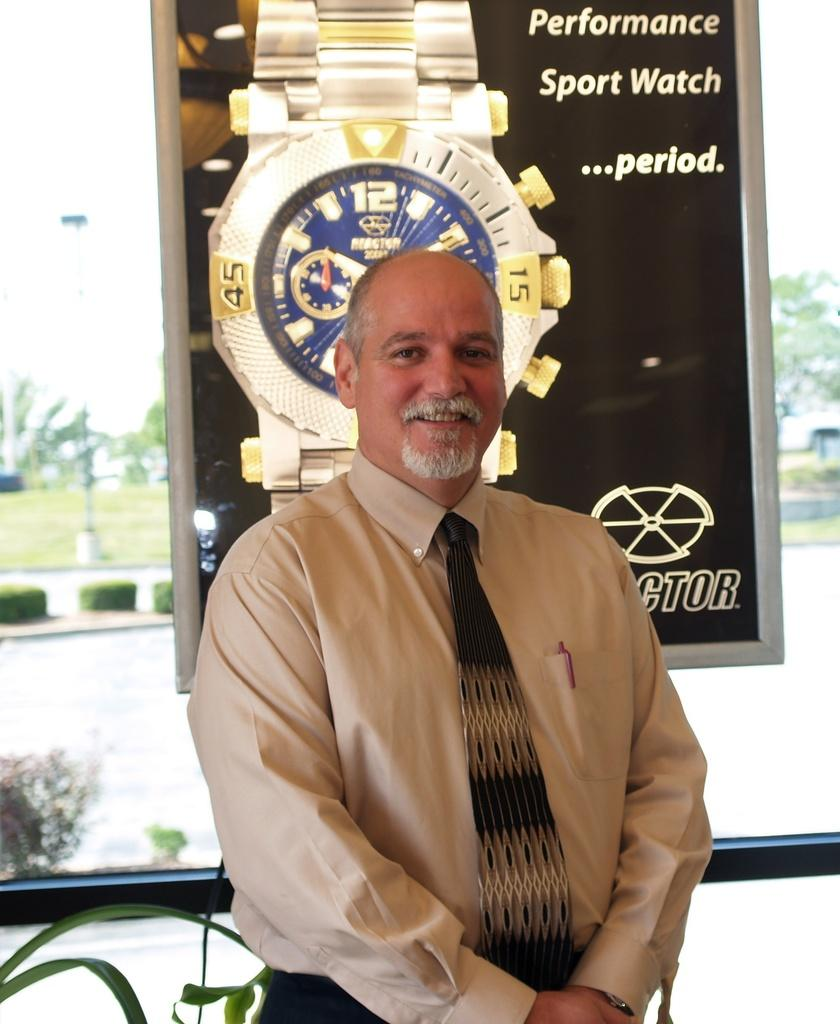<image>
Render a clear and concise summary of the photo. An advertisement for a watch with Performance Sport Watch on it. 